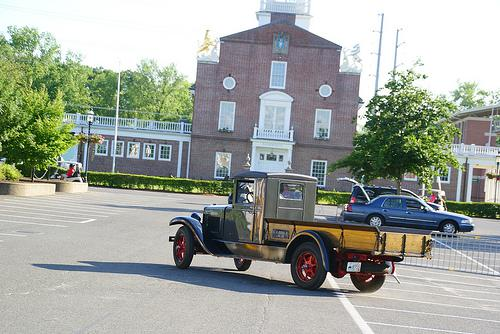Question: how many vehicles are there?
Choices:
A. 2.
B. 1.
C. 4.
D. 3.
Answer with the letter. Answer: D Question: what color is the pavement?
Choices:
A. Brown.
B. Grey.
C. White.
D. Black.
Answer with the letter. Answer: D Question: where was this taken?
Choices:
A. Parking lot.
B. Home.
C. Car.
D. School.
Answer with the letter. Answer: A Question: what color are the truck's rims?
Choices:
A. Grey.
B. Red.
C. Black.
D. White.
Answer with the letter. Answer: B 